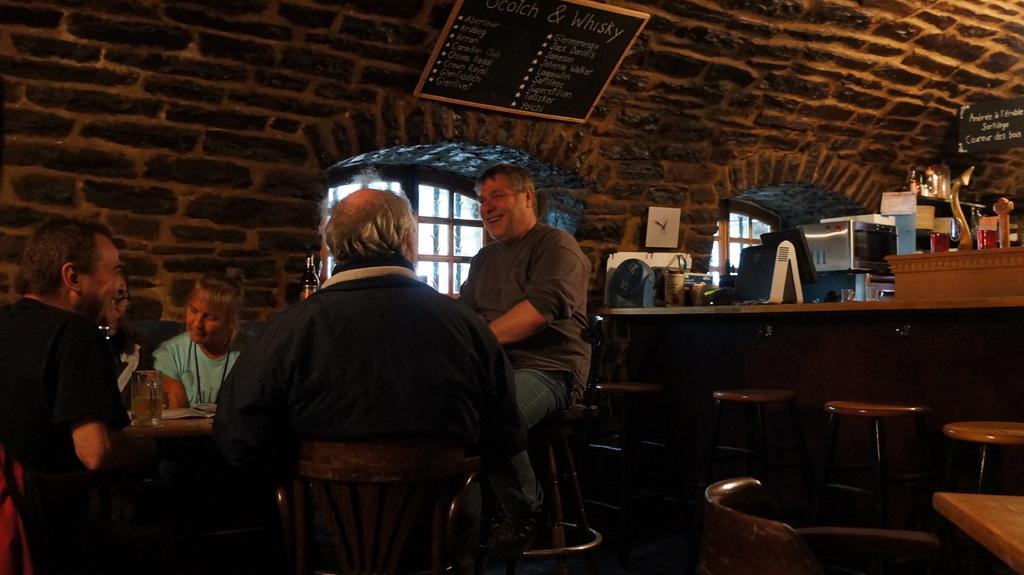Describe this image in one or two sentences. In this image I can see few people are sitting on the left side and on the right side of this image I can see few empty stools. In the background two black colour boards on the wall, a table and on it I can see number of stuffs. I can also see something is written on these boards and on the bottom left side of this image I can see a glass on the table. 